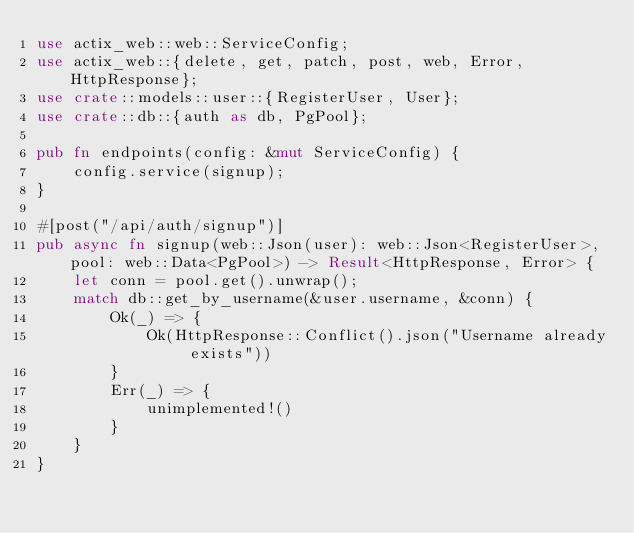Convert code to text. <code><loc_0><loc_0><loc_500><loc_500><_Rust_>use actix_web::web::ServiceConfig;
use actix_web::{delete, get, patch, post, web, Error, HttpResponse};
use crate::models::user::{RegisterUser, User};
use crate::db::{auth as db, PgPool};

pub fn endpoints(config: &mut ServiceConfig) {
    config.service(signup);
}

#[post("/api/auth/signup")]
pub async fn signup(web::Json(user): web::Json<RegisterUser>, pool: web::Data<PgPool>) -> Result<HttpResponse, Error> {
    let conn = pool.get().unwrap();
    match db::get_by_username(&user.username, &conn) {
        Ok(_) => {
            Ok(HttpResponse::Conflict().json("Username already exists"))
        }
        Err(_) => {
            unimplemented!()
        }
    }
}</code> 